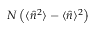Convert formula to latex. <formula><loc_0><loc_0><loc_500><loc_500>N \left ( \langle \hat { n } ^ { 2 } \rangle - \langle \hat { n } \rangle ^ { 2 } \right )</formula> 